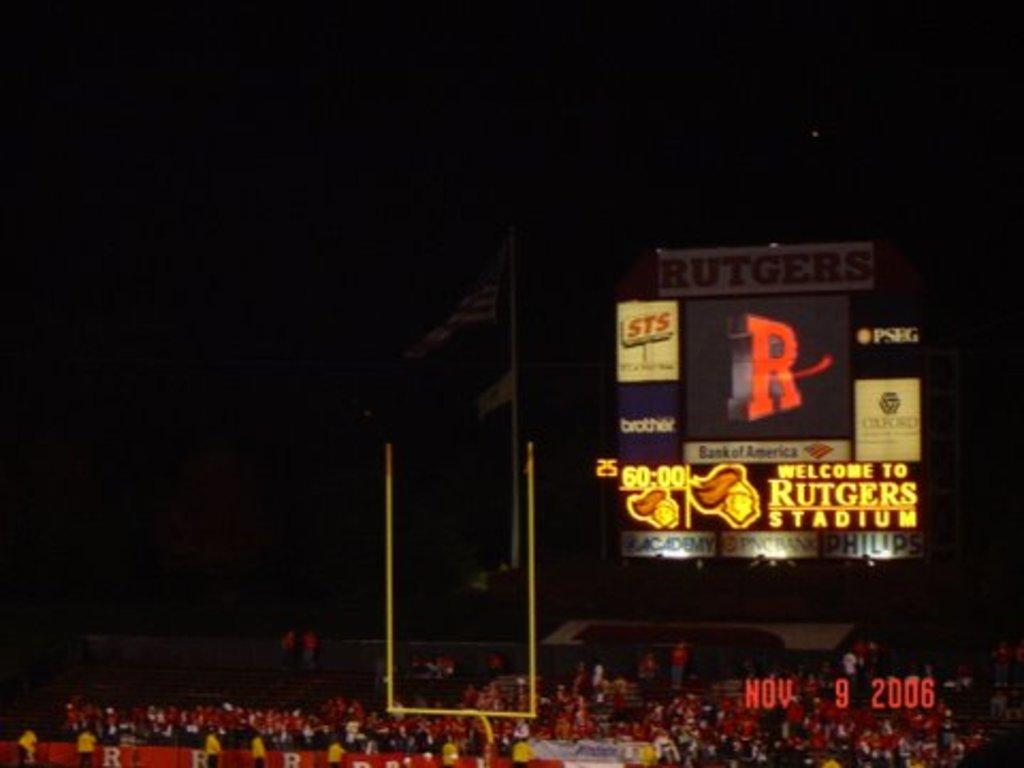<image>
Offer a succinct explanation of the picture presented. A football goal post is in the middle with Rutgers TV screen is in the background on the right. 